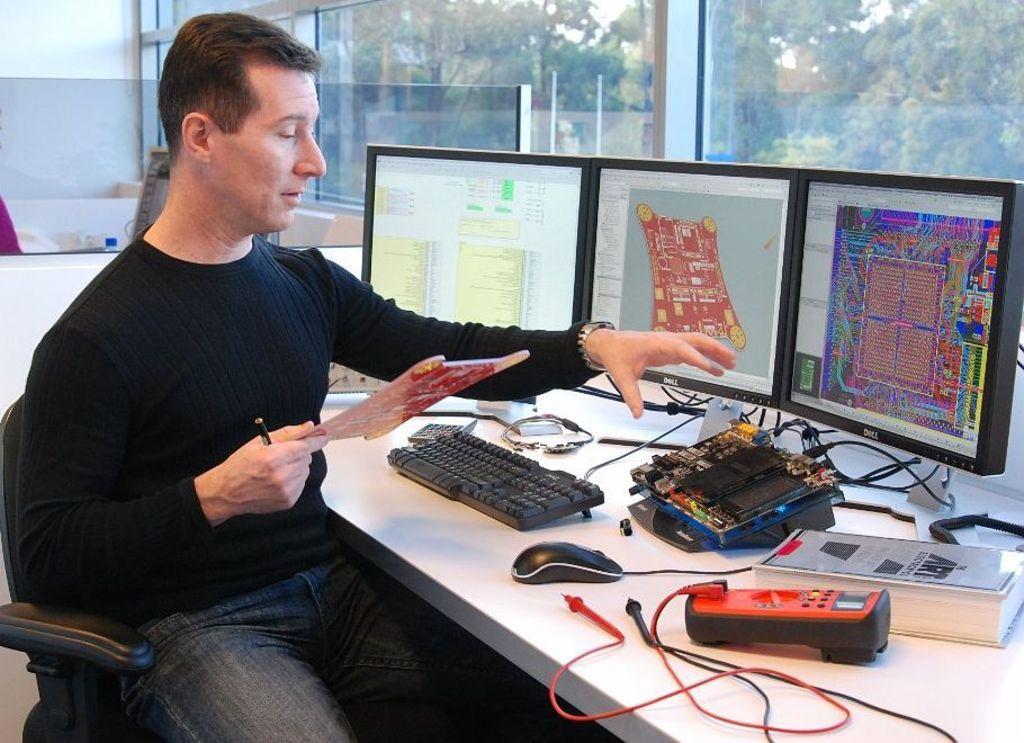Please provide a concise description of this image. In this image we can see persons sitting at the table. On the table we can see monitors, keyboard, electrical equipment, mouse, object and book. In the background we can see trees, windows and wall. 